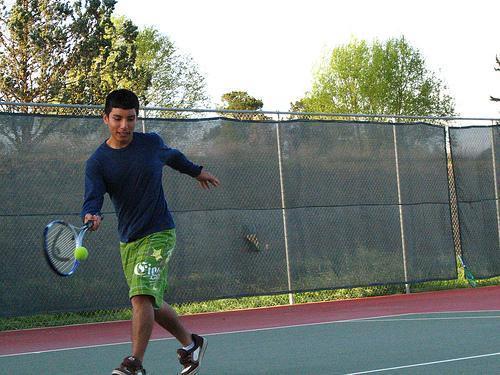How many people are in the photo?
Give a very brief answer. 1. 